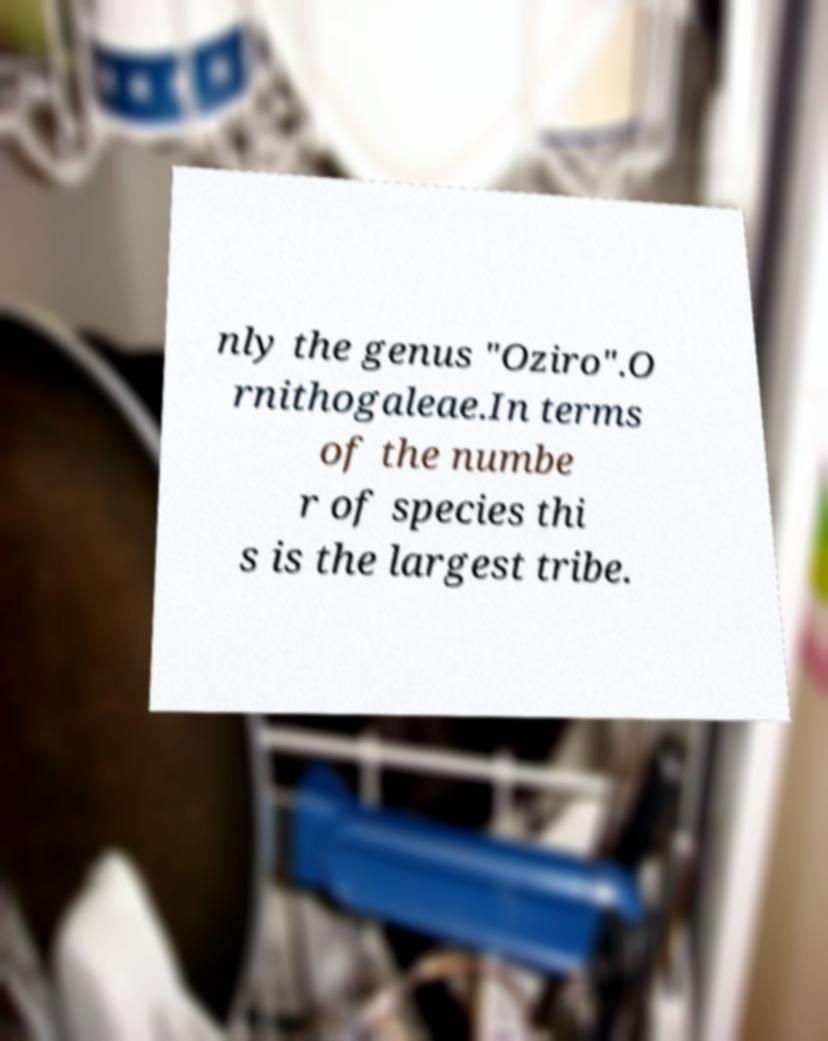There's text embedded in this image that I need extracted. Can you transcribe it verbatim? nly the genus "Oziro".O rnithogaleae.In terms of the numbe r of species thi s is the largest tribe. 